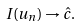<formula> <loc_0><loc_0><loc_500><loc_500>I ( u _ { n } ) \to \hat { c } .</formula> 